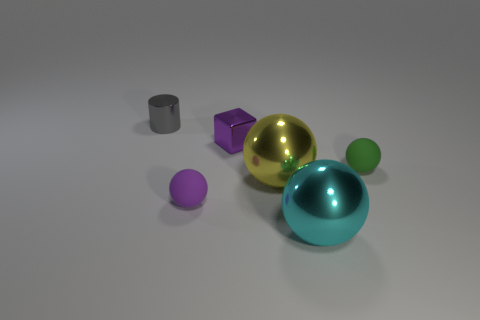Subtract 1 spheres. How many spheres are left? 3 Add 2 small purple cubes. How many objects exist? 8 Subtract all cylinders. How many objects are left? 5 Subtract 0 brown balls. How many objects are left? 6 Subtract all small gray blocks. Subtract all cubes. How many objects are left? 5 Add 4 gray metallic objects. How many gray metallic objects are left? 5 Add 4 large cyan cubes. How many large cyan cubes exist? 4 